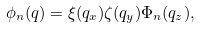<formula> <loc_0><loc_0><loc_500><loc_500>\phi _ { n } ( { q } ) = \xi ( q _ { x } ) \zeta ( q _ { y } ) \Phi _ { n } ( q _ { z } ) ,</formula> 